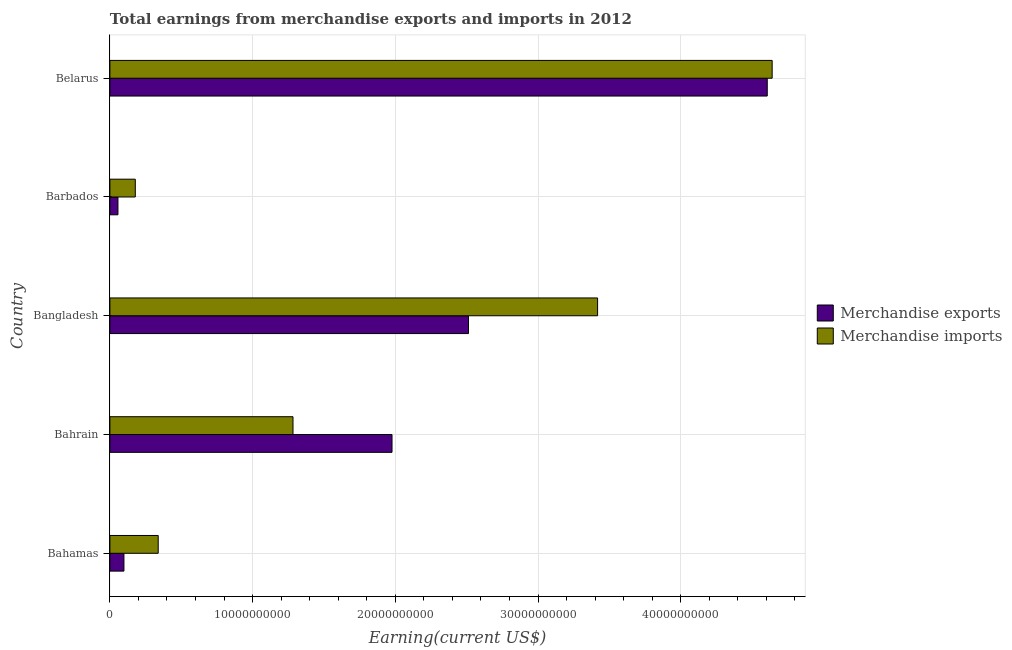How many groups of bars are there?
Provide a short and direct response. 5. Are the number of bars on each tick of the Y-axis equal?
Your response must be concise. Yes. What is the label of the 2nd group of bars from the top?
Offer a terse response. Barbados. What is the earnings from merchandise exports in Barbados?
Make the answer very short. 5.65e+08. Across all countries, what is the maximum earnings from merchandise imports?
Offer a very short reply. 4.64e+1. Across all countries, what is the minimum earnings from merchandise imports?
Your answer should be very brief. 1.78e+09. In which country was the earnings from merchandise imports maximum?
Make the answer very short. Belarus. In which country was the earnings from merchandise imports minimum?
Your answer should be very brief. Barbados. What is the total earnings from merchandise imports in the graph?
Offer a very short reply. 9.86e+1. What is the difference between the earnings from merchandise exports in Bangladesh and that in Barbados?
Make the answer very short. 2.46e+1. What is the difference between the earnings from merchandise exports in Bahrain and the earnings from merchandise imports in Belarus?
Provide a succinct answer. -2.66e+1. What is the average earnings from merchandise imports per country?
Make the answer very short. 1.97e+1. What is the difference between the earnings from merchandise imports and earnings from merchandise exports in Bahrain?
Keep it short and to the point. -6.94e+09. What is the ratio of the earnings from merchandise exports in Bahrain to that in Barbados?
Offer a very short reply. 34.98. Is the difference between the earnings from merchandise exports in Bahamas and Bahrain greater than the difference between the earnings from merchandise imports in Bahamas and Bahrain?
Ensure brevity in your answer.  No. What is the difference between the highest and the second highest earnings from merchandise imports?
Ensure brevity in your answer.  1.22e+1. What is the difference between the highest and the lowest earnings from merchandise exports?
Make the answer very short. 4.55e+1. What does the 1st bar from the bottom in Bangladesh represents?
Give a very brief answer. Merchandise exports. How many bars are there?
Ensure brevity in your answer.  10. How many countries are there in the graph?
Your response must be concise. 5. Are the values on the major ticks of X-axis written in scientific E-notation?
Make the answer very short. No. Where does the legend appear in the graph?
Your answer should be compact. Center right. How many legend labels are there?
Your answer should be very brief. 2. How are the legend labels stacked?
Give a very brief answer. Vertical. What is the title of the graph?
Provide a short and direct response. Total earnings from merchandise exports and imports in 2012. Does "Banks" appear as one of the legend labels in the graph?
Offer a very short reply. No. What is the label or title of the X-axis?
Your answer should be very brief. Earning(current US$). What is the label or title of the Y-axis?
Offer a very short reply. Country. What is the Earning(current US$) of Merchandise exports in Bahamas?
Provide a short and direct response. 9.84e+08. What is the Earning(current US$) of Merchandise imports in Bahamas?
Ensure brevity in your answer.  3.39e+09. What is the Earning(current US$) in Merchandise exports in Bahrain?
Offer a very short reply. 1.98e+1. What is the Earning(current US$) of Merchandise imports in Bahrain?
Make the answer very short. 1.28e+1. What is the Earning(current US$) in Merchandise exports in Bangladesh?
Offer a terse response. 2.51e+1. What is the Earning(current US$) of Merchandise imports in Bangladesh?
Your response must be concise. 3.42e+1. What is the Earning(current US$) of Merchandise exports in Barbados?
Make the answer very short. 5.65e+08. What is the Earning(current US$) in Merchandise imports in Barbados?
Give a very brief answer. 1.78e+09. What is the Earning(current US$) in Merchandise exports in Belarus?
Provide a short and direct response. 4.61e+1. What is the Earning(current US$) in Merchandise imports in Belarus?
Ensure brevity in your answer.  4.64e+1. Across all countries, what is the maximum Earning(current US$) in Merchandise exports?
Provide a succinct answer. 4.61e+1. Across all countries, what is the maximum Earning(current US$) of Merchandise imports?
Provide a succinct answer. 4.64e+1. Across all countries, what is the minimum Earning(current US$) of Merchandise exports?
Give a very brief answer. 5.65e+08. Across all countries, what is the minimum Earning(current US$) in Merchandise imports?
Offer a terse response. 1.78e+09. What is the total Earning(current US$) of Merchandise exports in the graph?
Provide a short and direct response. 9.25e+1. What is the total Earning(current US$) in Merchandise imports in the graph?
Make the answer very short. 9.86e+1. What is the difference between the Earning(current US$) in Merchandise exports in Bahamas and that in Bahrain?
Your answer should be very brief. -1.88e+1. What is the difference between the Earning(current US$) of Merchandise imports in Bahamas and that in Bahrain?
Give a very brief answer. -9.44e+09. What is the difference between the Earning(current US$) of Merchandise exports in Bahamas and that in Bangladesh?
Offer a terse response. -2.41e+1. What is the difference between the Earning(current US$) in Merchandise imports in Bahamas and that in Bangladesh?
Your response must be concise. -3.08e+1. What is the difference between the Earning(current US$) in Merchandise exports in Bahamas and that in Barbados?
Make the answer very short. 4.19e+08. What is the difference between the Earning(current US$) of Merchandise imports in Bahamas and that in Barbados?
Give a very brief answer. 1.61e+09. What is the difference between the Earning(current US$) of Merchandise exports in Bahamas and that in Belarus?
Your response must be concise. -4.51e+1. What is the difference between the Earning(current US$) of Merchandise imports in Bahamas and that in Belarus?
Ensure brevity in your answer.  -4.30e+1. What is the difference between the Earning(current US$) in Merchandise exports in Bahrain and that in Bangladesh?
Your response must be concise. -5.36e+09. What is the difference between the Earning(current US$) in Merchandise imports in Bahrain and that in Bangladesh?
Offer a very short reply. -2.13e+1. What is the difference between the Earning(current US$) in Merchandise exports in Bahrain and that in Barbados?
Make the answer very short. 1.92e+1. What is the difference between the Earning(current US$) in Merchandise imports in Bahrain and that in Barbados?
Provide a succinct answer. 1.11e+1. What is the difference between the Earning(current US$) in Merchandise exports in Bahrain and that in Belarus?
Keep it short and to the point. -2.63e+1. What is the difference between the Earning(current US$) of Merchandise imports in Bahrain and that in Belarus?
Give a very brief answer. -3.36e+1. What is the difference between the Earning(current US$) of Merchandise exports in Bangladesh and that in Barbados?
Offer a very short reply. 2.46e+1. What is the difference between the Earning(current US$) of Merchandise imports in Bangladesh and that in Barbados?
Offer a very short reply. 3.24e+1. What is the difference between the Earning(current US$) in Merchandise exports in Bangladesh and that in Belarus?
Keep it short and to the point. -2.09e+1. What is the difference between the Earning(current US$) of Merchandise imports in Bangladesh and that in Belarus?
Offer a very short reply. -1.22e+1. What is the difference between the Earning(current US$) in Merchandise exports in Barbados and that in Belarus?
Keep it short and to the point. -4.55e+1. What is the difference between the Earning(current US$) of Merchandise imports in Barbados and that in Belarus?
Give a very brief answer. -4.46e+1. What is the difference between the Earning(current US$) of Merchandise exports in Bahamas and the Earning(current US$) of Merchandise imports in Bahrain?
Make the answer very short. -1.18e+1. What is the difference between the Earning(current US$) in Merchandise exports in Bahamas and the Earning(current US$) in Merchandise imports in Bangladesh?
Keep it short and to the point. -3.32e+1. What is the difference between the Earning(current US$) of Merchandise exports in Bahamas and the Earning(current US$) of Merchandise imports in Barbados?
Make the answer very short. -7.96e+08. What is the difference between the Earning(current US$) in Merchandise exports in Bahamas and the Earning(current US$) in Merchandise imports in Belarus?
Your response must be concise. -4.54e+1. What is the difference between the Earning(current US$) of Merchandise exports in Bahrain and the Earning(current US$) of Merchandise imports in Bangladesh?
Ensure brevity in your answer.  -1.44e+1. What is the difference between the Earning(current US$) of Merchandise exports in Bahrain and the Earning(current US$) of Merchandise imports in Barbados?
Ensure brevity in your answer.  1.80e+1. What is the difference between the Earning(current US$) of Merchandise exports in Bahrain and the Earning(current US$) of Merchandise imports in Belarus?
Offer a terse response. -2.66e+1. What is the difference between the Earning(current US$) of Merchandise exports in Bangladesh and the Earning(current US$) of Merchandise imports in Barbados?
Your answer should be very brief. 2.33e+1. What is the difference between the Earning(current US$) in Merchandise exports in Bangladesh and the Earning(current US$) in Merchandise imports in Belarus?
Your answer should be compact. -2.13e+1. What is the difference between the Earning(current US$) in Merchandise exports in Barbados and the Earning(current US$) in Merchandise imports in Belarus?
Offer a terse response. -4.58e+1. What is the average Earning(current US$) in Merchandise exports per country?
Provide a short and direct response. 1.85e+1. What is the average Earning(current US$) of Merchandise imports per country?
Your response must be concise. 1.97e+1. What is the difference between the Earning(current US$) in Merchandise exports and Earning(current US$) in Merchandise imports in Bahamas?
Provide a short and direct response. -2.40e+09. What is the difference between the Earning(current US$) in Merchandise exports and Earning(current US$) in Merchandise imports in Bahrain?
Your answer should be compact. 6.94e+09. What is the difference between the Earning(current US$) of Merchandise exports and Earning(current US$) of Merchandise imports in Bangladesh?
Make the answer very short. -9.05e+09. What is the difference between the Earning(current US$) in Merchandise exports and Earning(current US$) in Merchandise imports in Barbados?
Provide a succinct answer. -1.21e+09. What is the difference between the Earning(current US$) of Merchandise exports and Earning(current US$) of Merchandise imports in Belarus?
Your response must be concise. -3.44e+08. What is the ratio of the Earning(current US$) in Merchandise exports in Bahamas to that in Bahrain?
Keep it short and to the point. 0.05. What is the ratio of the Earning(current US$) in Merchandise imports in Bahamas to that in Bahrain?
Make the answer very short. 0.26. What is the ratio of the Earning(current US$) in Merchandise exports in Bahamas to that in Bangladesh?
Your answer should be compact. 0.04. What is the ratio of the Earning(current US$) in Merchandise imports in Bahamas to that in Bangladesh?
Your answer should be very brief. 0.1. What is the ratio of the Earning(current US$) of Merchandise exports in Bahamas to that in Barbados?
Make the answer very short. 1.74. What is the ratio of the Earning(current US$) in Merchandise imports in Bahamas to that in Barbados?
Your answer should be very brief. 1.9. What is the ratio of the Earning(current US$) in Merchandise exports in Bahamas to that in Belarus?
Keep it short and to the point. 0.02. What is the ratio of the Earning(current US$) in Merchandise imports in Bahamas to that in Belarus?
Your response must be concise. 0.07. What is the ratio of the Earning(current US$) of Merchandise exports in Bahrain to that in Bangladesh?
Your answer should be compact. 0.79. What is the ratio of the Earning(current US$) of Merchandise imports in Bahrain to that in Bangladesh?
Your response must be concise. 0.38. What is the ratio of the Earning(current US$) in Merchandise exports in Bahrain to that in Barbados?
Offer a terse response. 34.99. What is the ratio of the Earning(current US$) in Merchandise imports in Bahrain to that in Barbados?
Your answer should be compact. 7.21. What is the ratio of the Earning(current US$) of Merchandise exports in Bahrain to that in Belarus?
Your answer should be compact. 0.43. What is the ratio of the Earning(current US$) in Merchandise imports in Bahrain to that in Belarus?
Your answer should be compact. 0.28. What is the ratio of the Earning(current US$) in Merchandise exports in Bangladesh to that in Barbados?
Offer a terse response. 44.47. What is the ratio of the Earning(current US$) in Merchandise imports in Bangladesh to that in Barbados?
Ensure brevity in your answer.  19.2. What is the ratio of the Earning(current US$) in Merchandise exports in Bangladesh to that in Belarus?
Your response must be concise. 0.55. What is the ratio of the Earning(current US$) of Merchandise imports in Bangladesh to that in Belarus?
Your response must be concise. 0.74. What is the ratio of the Earning(current US$) in Merchandise exports in Barbados to that in Belarus?
Give a very brief answer. 0.01. What is the ratio of the Earning(current US$) in Merchandise imports in Barbados to that in Belarus?
Your response must be concise. 0.04. What is the difference between the highest and the second highest Earning(current US$) in Merchandise exports?
Ensure brevity in your answer.  2.09e+1. What is the difference between the highest and the second highest Earning(current US$) in Merchandise imports?
Offer a very short reply. 1.22e+1. What is the difference between the highest and the lowest Earning(current US$) in Merchandise exports?
Make the answer very short. 4.55e+1. What is the difference between the highest and the lowest Earning(current US$) in Merchandise imports?
Provide a short and direct response. 4.46e+1. 